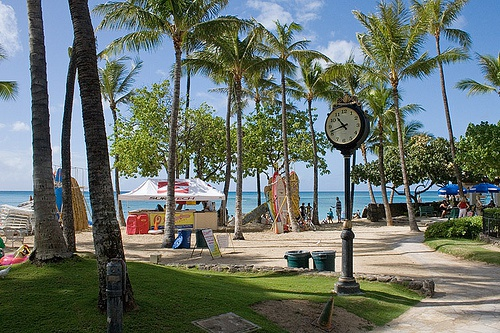Describe the objects in this image and their specific colors. I can see clock in darkgray, black, and gray tones, people in darkgray, maroon, gray, and black tones, people in darkgray, black, gray, and darkblue tones, people in darkgray, gray, and black tones, and bench in darkgray, black, and teal tones in this image. 